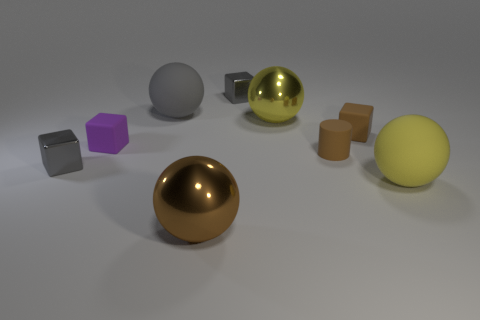What shape is the purple thing that is the same size as the brown cube?
Offer a terse response. Cube. What is the color of the other big shiny object that is the same shape as the big brown shiny thing?
Offer a very short reply. Yellow. What number of things are either yellow rubber things or tiny metallic cylinders?
Ensure brevity in your answer.  1. Do the tiny shiny object in front of the purple block and the tiny gray metallic thing behind the yellow metal thing have the same shape?
Keep it short and to the point. Yes. What is the shape of the big matte thing in front of the gray ball?
Offer a very short reply. Sphere. Are there an equal number of objects that are behind the brown cylinder and purple matte things to the right of the tiny purple rubber object?
Your response must be concise. No. What number of objects are big red shiny cubes or large matte things that are in front of the big gray object?
Make the answer very short. 1. There is a big object that is on the left side of the large yellow metallic thing and behind the brown matte cylinder; what shape is it?
Give a very brief answer. Sphere. What material is the big yellow ball behind the small shiny cube on the left side of the large brown metallic sphere?
Offer a very short reply. Metal. Are the gray block to the right of the large brown object and the purple block made of the same material?
Your answer should be compact. No. 